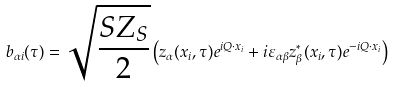Convert formula to latex. <formula><loc_0><loc_0><loc_500><loc_500>b _ { \alpha i } ( \tau ) = \sqrt { \frac { S Z _ { S } } { 2 } } \left ( z _ { \alpha } ( { x } _ { i } , \tau ) e ^ { i { Q } \cdot { x } _ { i } } + i \varepsilon _ { \alpha \beta } z _ { \beta } ^ { \ast } ( { x } _ { i } , \tau ) e ^ { - i { Q } \cdot { x } _ { i } } \right )</formula> 